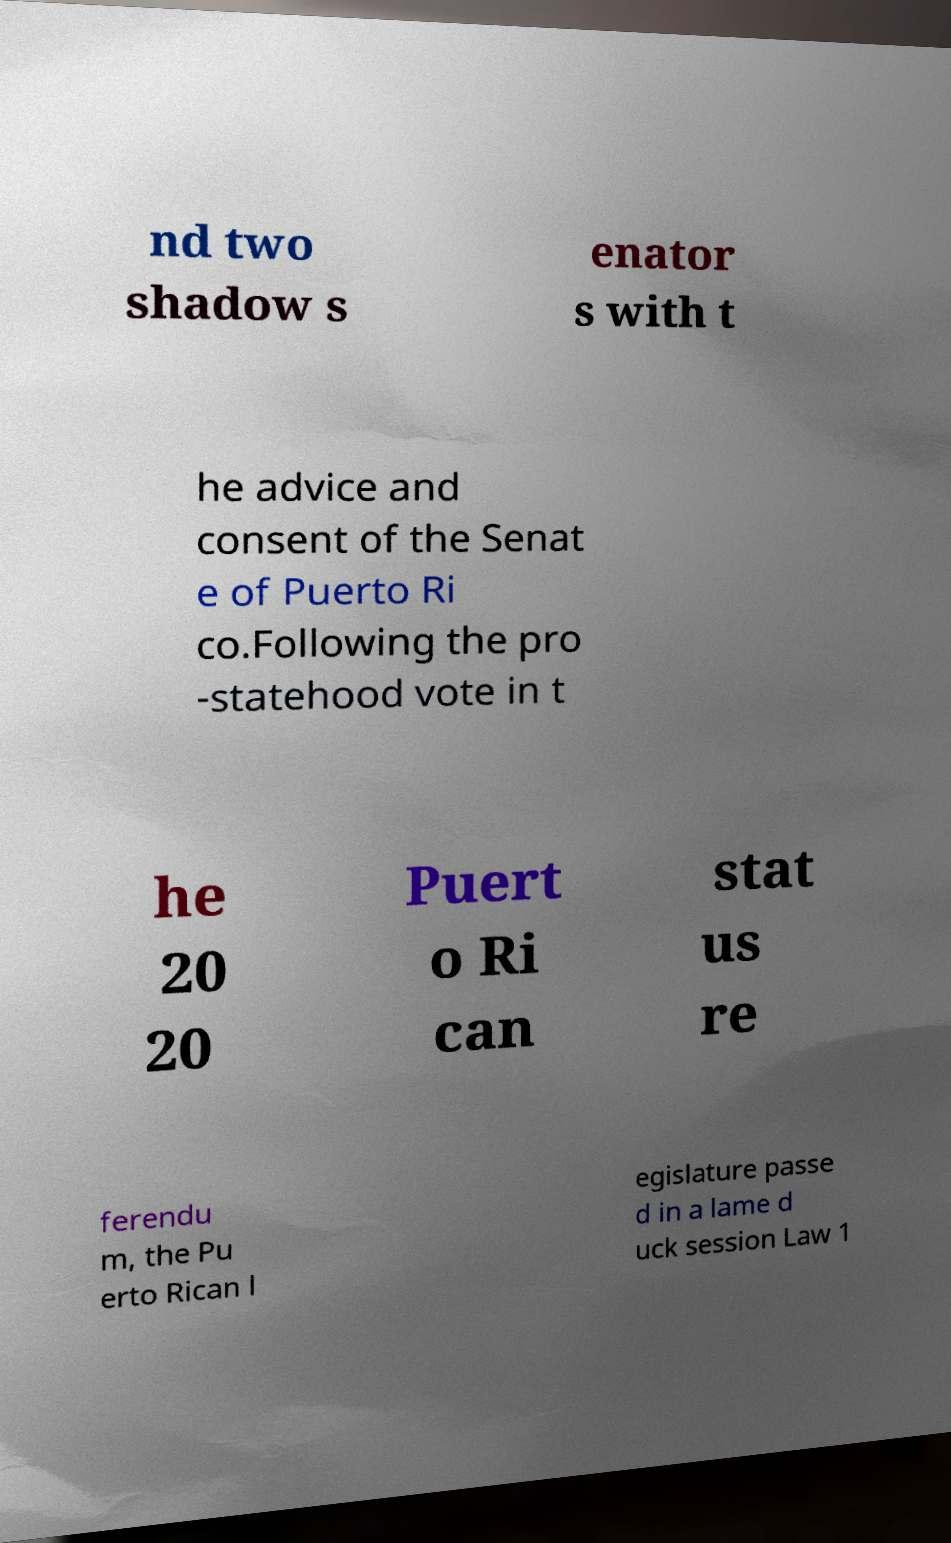There's text embedded in this image that I need extracted. Can you transcribe it verbatim? nd two shadow s enator s with t he advice and consent of the Senat e of Puerto Ri co.Following the pro -statehood vote in t he 20 20 Puert o Ri can stat us re ferendu m, the Pu erto Rican l egislature passe d in a lame d uck session Law 1 